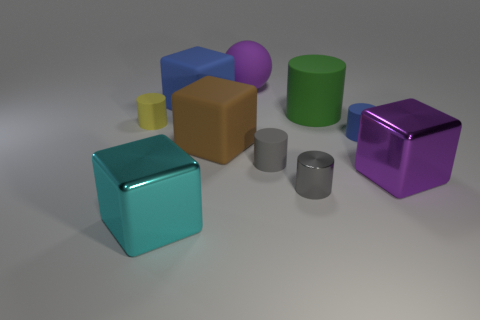Which objects in the image have a cubic shape, and what colors are they? The objects with a cubic shape are the blue and the brown ones. Additionally, there is a turquoise cube that is slightly transparent, which could be considered as having a cubic shape as well. 